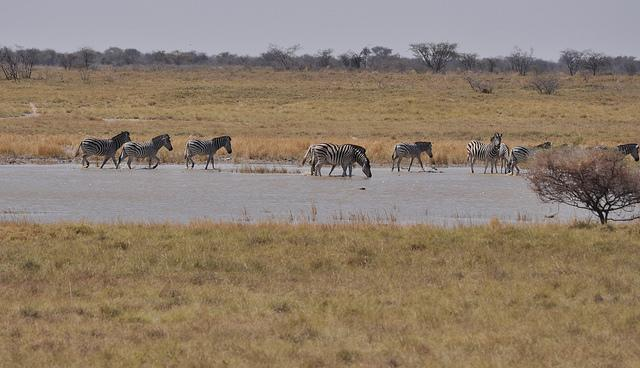What are the zebras all standing inside of? Please explain your reasoning. stream. The zebras are standing inside of a stream to drink water and cool off. 